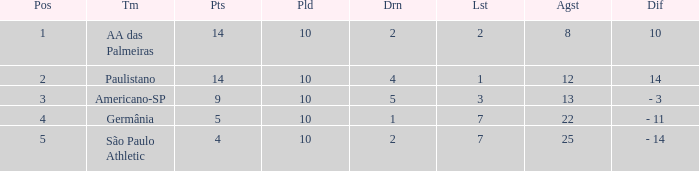What is the lowest Against when the played is more than 10? None. Could you parse the entire table? {'header': ['Pos', 'Tm', 'Pts', 'Pld', 'Drn', 'Lst', 'Agst', 'Dif'], 'rows': [['1', 'AA das Palmeiras', '14', '10', '2', '2', '8', '10'], ['2', 'Paulistano', '14', '10', '4', '1', '12', '14'], ['3', 'Americano-SP', '9', '10', '5', '3', '13', '- 3'], ['4', 'Germânia', '5', '10', '1', '7', '22', '- 11'], ['5', 'São Paulo Athletic', '4', '10', '2', '7', '25', '- 14']]} 